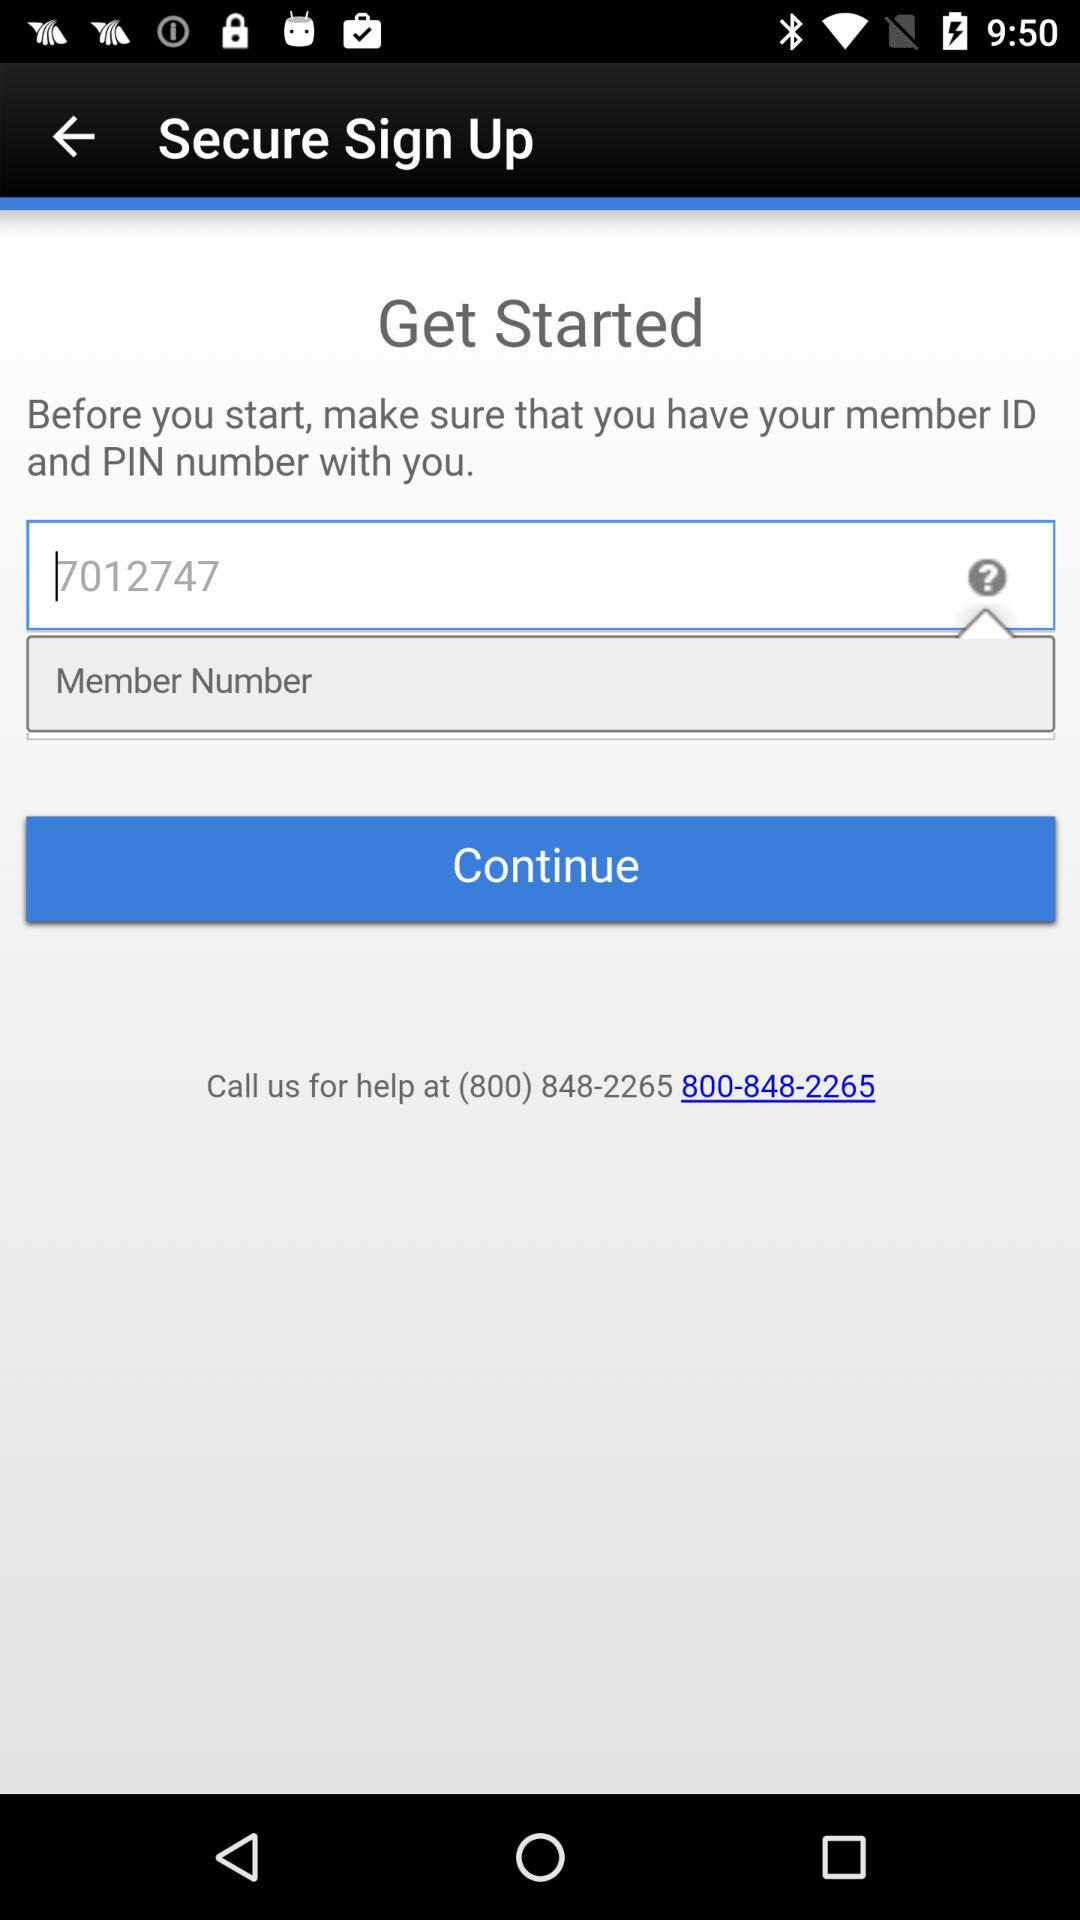What is the given helpline number? The given helpline number is (800) 848-2265. 